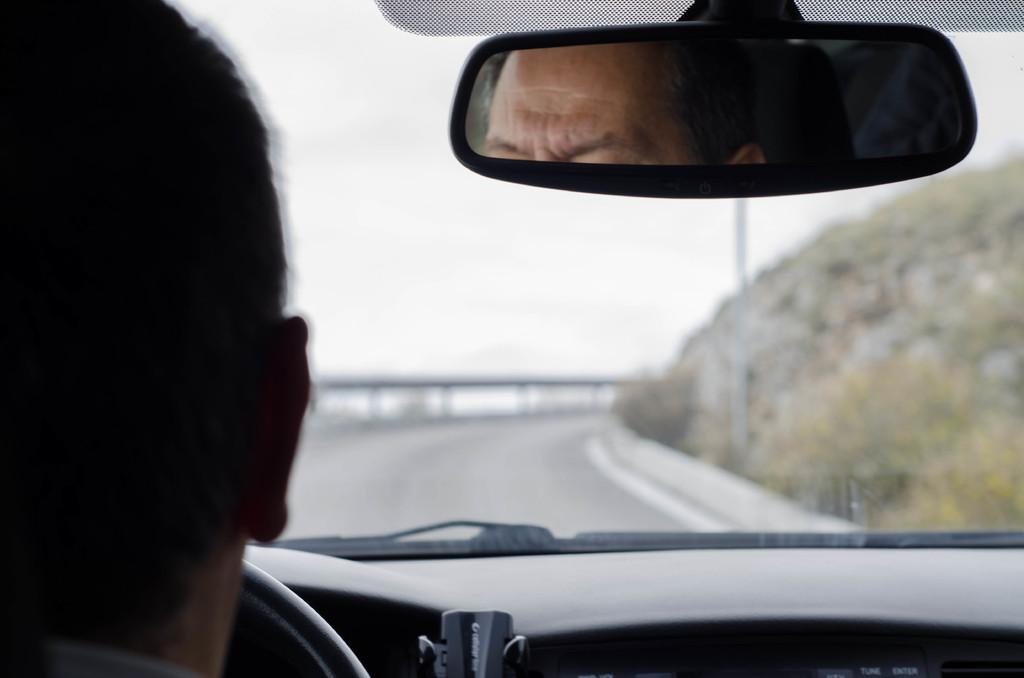What is the person inside in the image? The person is inside a vehicle. How can the person be seen in the image? The person is visible in a mirror. What part of the vehicle is visible in the image? The windshield of the vehicle is visible. What can be seen through the windshield? The road, sky, fence, and plants are visible through the windshield. What type of sheet is being used to write prose in the image? There is no sheet or prose present in the image; it features a person inside a vehicle with a visible windshield. What color is the pencil used by the person to draw in the image? There is no pencil or drawing activity present in the image. 